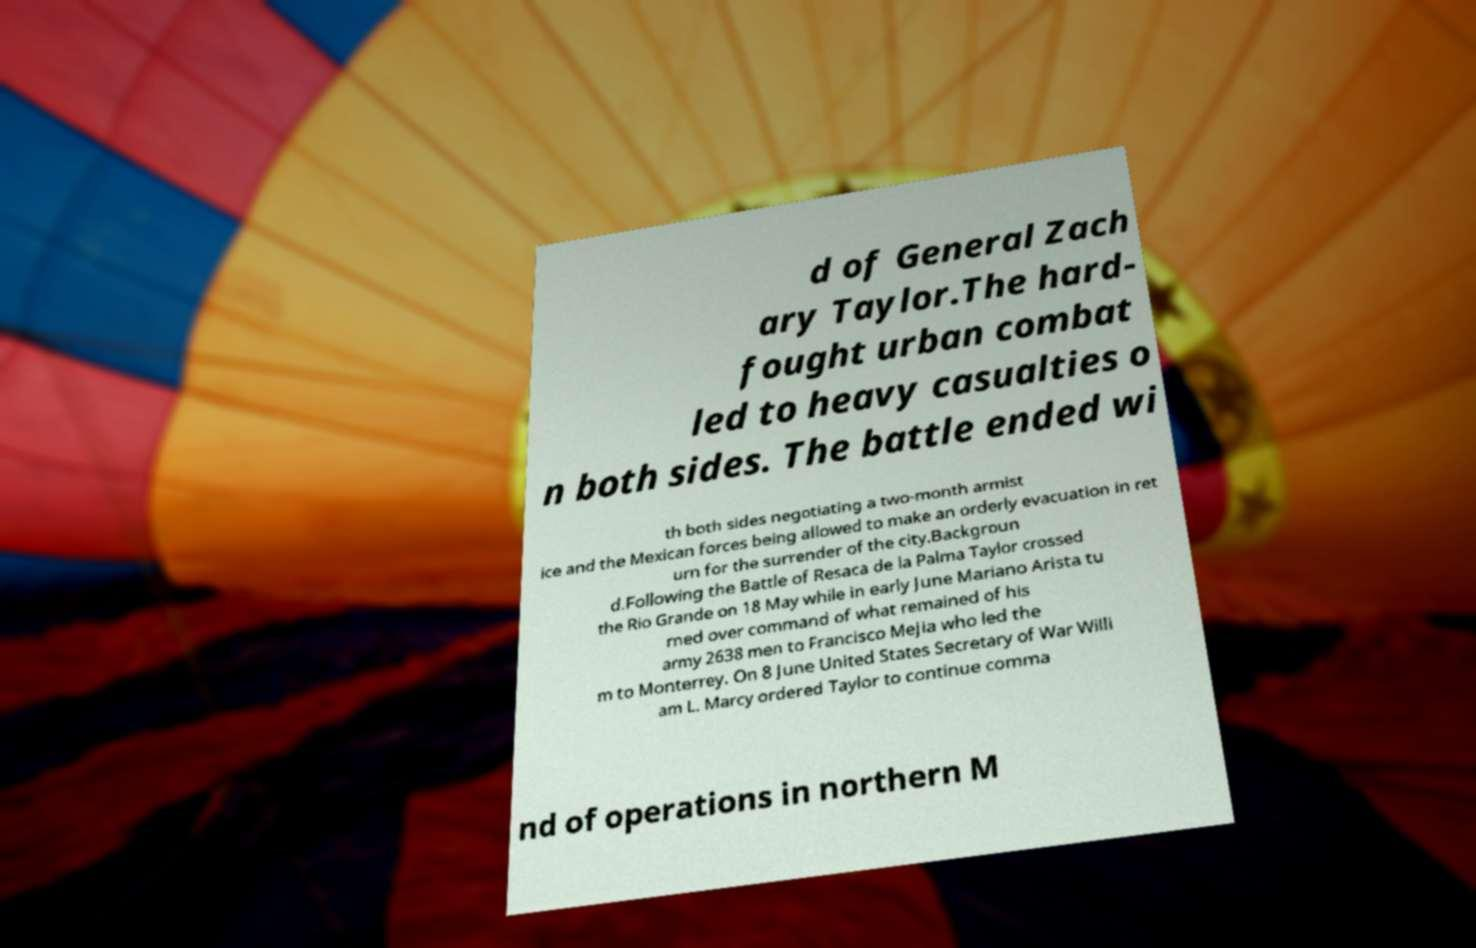Can you read and provide the text displayed in the image?This photo seems to have some interesting text. Can you extract and type it out for me? d of General Zach ary Taylor.The hard- fought urban combat led to heavy casualties o n both sides. The battle ended wi th both sides negotiating a two-month armist ice and the Mexican forces being allowed to make an orderly evacuation in ret urn for the surrender of the city.Backgroun d.Following the Battle of Resaca de la Palma Taylor crossed the Rio Grande on 18 May while in early June Mariano Arista tu rned over command of what remained of his army 2638 men to Francisco Mejia who led the m to Monterrey. On 8 June United States Secretary of War Willi am L. Marcy ordered Taylor to continue comma nd of operations in northern M 